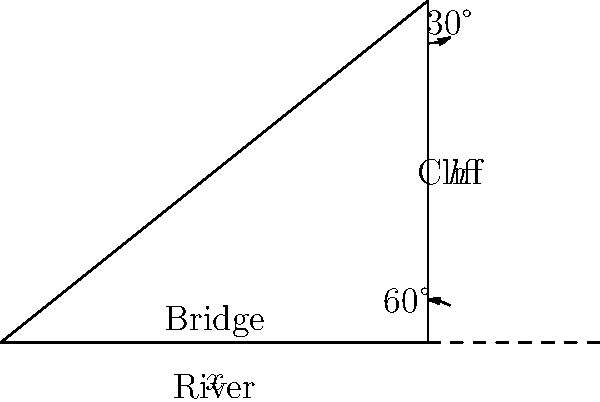During a local festival, you notice a rope bridge spanning a river gorge. From the top of a nearby cliff, you observe that the angle of depression to the near end of the bridge is 60°, while the angle of depression to the far end is 30°. If the height of the cliff is 80 meters, what is the length of the rope bridge? Let's approach this step-by-step:

1) Let $x$ be the length of the bridge and $h$ the height of the cliff.

2) We're given that $h = 80$ meters.

3) For the near end of the bridge:
   $\tan 60° = \frac{h}{y}$, where $y$ is the horizontal distance to the near end.
   $y = \frac{h}{\tan 60°} = \frac{80}{\sqrt{3}} \approx 46.19$ meters

4) For the far end of the bridge:
   $\tan 30° = \frac{h}{y+x}$
   $\frac{1}{\sqrt{3}} = \frac{80}{y+x}$
   $y + x = 80\sqrt{3} \approx 138.56$ meters

5) The length of the bridge $x$ is the difference between these two distances:
   $x = (y+x) - y = 80\sqrt{3} - \frac{80}{\sqrt{3}}$

6) Simplifying:
   $x = 80(\sqrt{3} - \frac{1}{\sqrt{3}}) = 80(\frac{3-1}{\sqrt{3}}) = 80 \cdot \frac{2}{\sqrt{3}} = \frac{160}{\sqrt{3}}$

7) Calculate the final value:
   $x = \frac{160}{\sqrt{3}} \approx 92.38$ meters
Answer: $\frac{160}{\sqrt{3}}$ meters (or approximately 92.38 meters) 